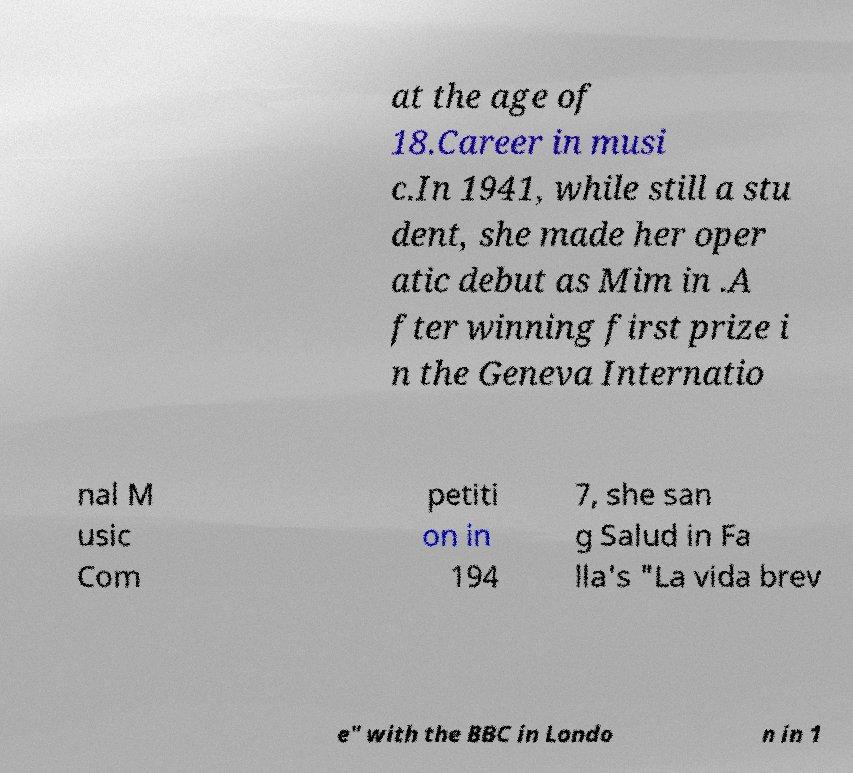For documentation purposes, I need the text within this image transcribed. Could you provide that? at the age of 18.Career in musi c.In 1941, while still a stu dent, she made her oper atic debut as Mim in .A fter winning first prize i n the Geneva Internatio nal M usic Com petiti on in 194 7, she san g Salud in Fa lla's "La vida brev e" with the BBC in Londo n in 1 